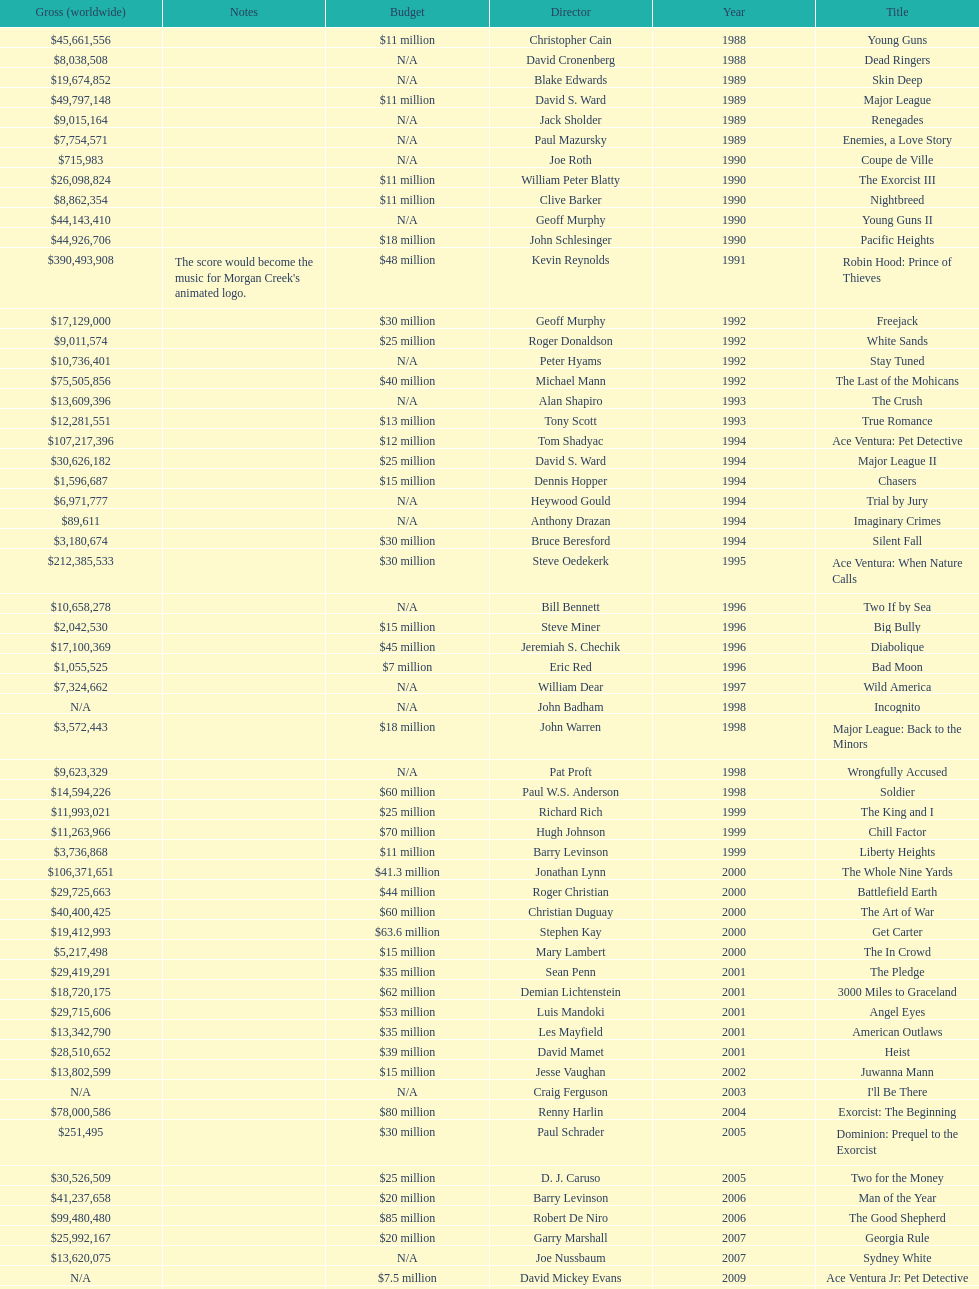Which morgan creek film grossed the most worldwide? Robin Hood: Prince of Thieves. 